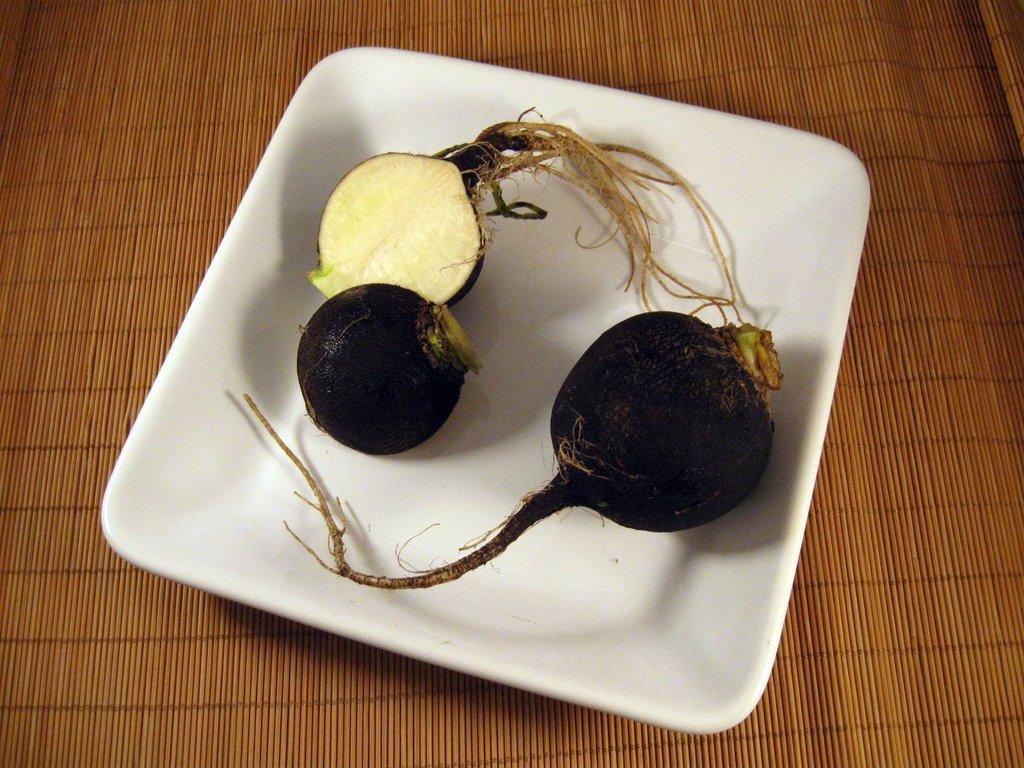Can you describe this image briefly? In this image there is a table, on that table there is a plate, in that place there are fruits. 